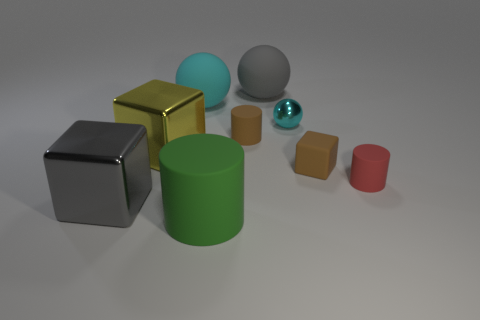There is a rubber thing that is the same color as the small shiny object; what is its shape?
Your response must be concise. Sphere. There is a small cylinder that is the same color as the rubber cube; what material is it?
Your response must be concise. Rubber. Do the block on the left side of the large yellow metallic thing and the big rubber sphere that is right of the big green matte thing have the same color?
Your response must be concise. Yes. What shape is the cyan thing that is right of the gray thing behind the small brown cylinder?
Your answer should be very brief. Sphere. Are there any tiny brown objects in front of the brown cylinder?
Offer a terse response. Yes. What is the color of the cube that is the same size as the cyan shiny object?
Give a very brief answer. Brown. How many brown balls have the same material as the large cyan sphere?
Make the answer very short. 0. How many other things are the same size as the rubber block?
Provide a succinct answer. 3. Are there any matte cylinders that have the same size as the red thing?
Offer a terse response. Yes. Do the ball that is to the left of the tiny brown cylinder and the small metallic sphere have the same color?
Your answer should be compact. Yes. 